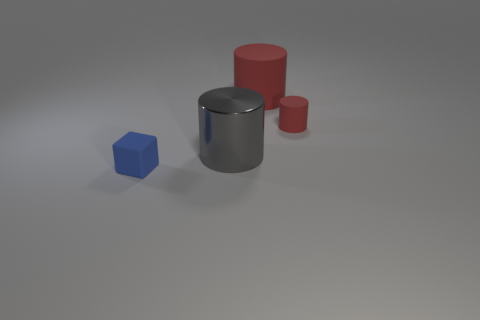Is the large red cylinder made of the same material as the large gray thing?
Your answer should be compact. No. There is a large thing that is right of the big gray shiny cylinder; what shape is it?
Give a very brief answer. Cylinder. There is another cylinder that is the same material as the small cylinder; what is its size?
Your answer should be very brief. Large. What shape is the matte thing that is both in front of the large red matte cylinder and right of the gray metal object?
Ensure brevity in your answer.  Cylinder. There is a rubber thing that is behind the tiny matte cylinder; is it the same color as the tiny rubber cylinder?
Give a very brief answer. Yes. There is a red matte thing in front of the large red matte cylinder; is its shape the same as the rubber object behind the tiny red cylinder?
Your response must be concise. Yes. There is a rubber object in front of the small cylinder; how big is it?
Provide a succinct answer. Small. There is a cube that is in front of the tiny rubber thing that is to the right of the tiny block; what size is it?
Give a very brief answer. Small. Is the number of tiny gray shiny spheres greater than the number of tiny cubes?
Your response must be concise. No. Are there more small rubber objects behind the small blue rubber object than red cylinders on the left side of the metal object?
Provide a succinct answer. Yes. 